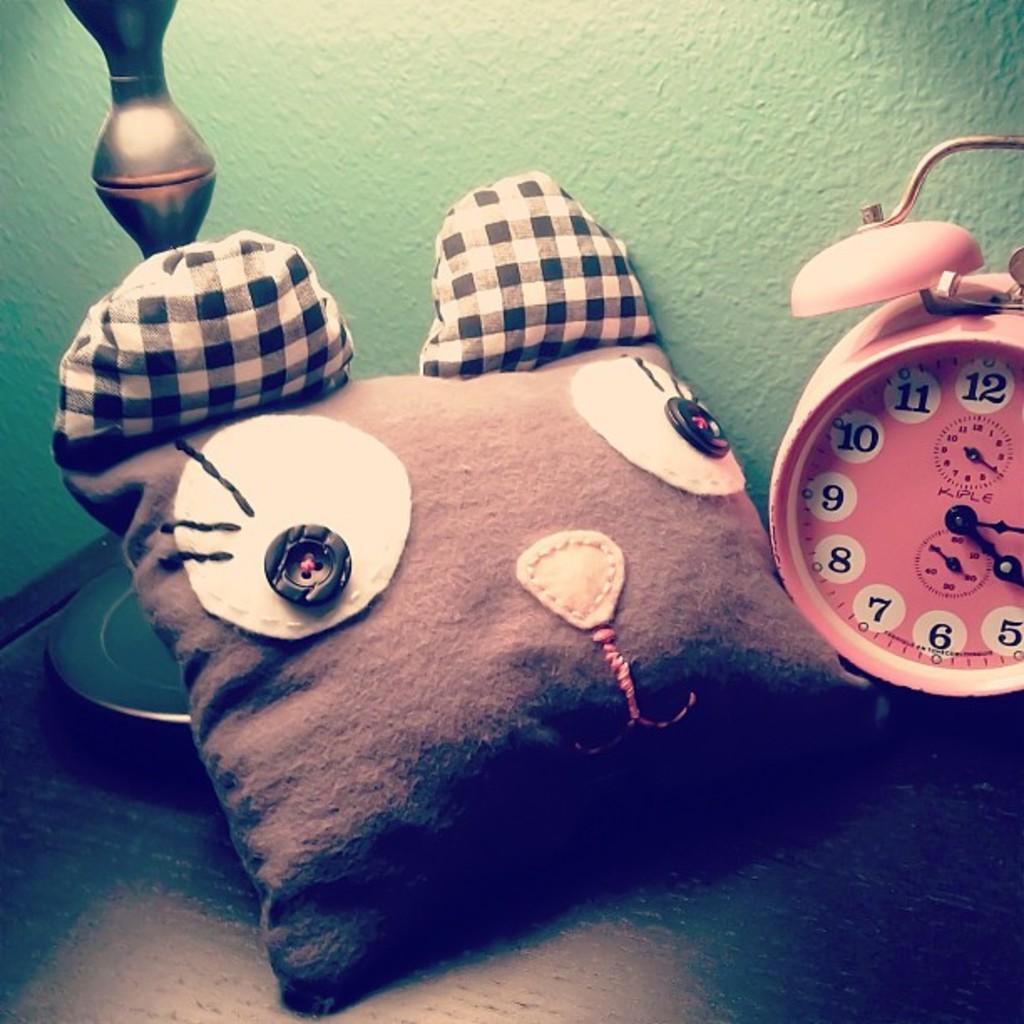<image>
Summarize the visual content of the image. A pink alarm clock displays numbers from 5 to 12. 